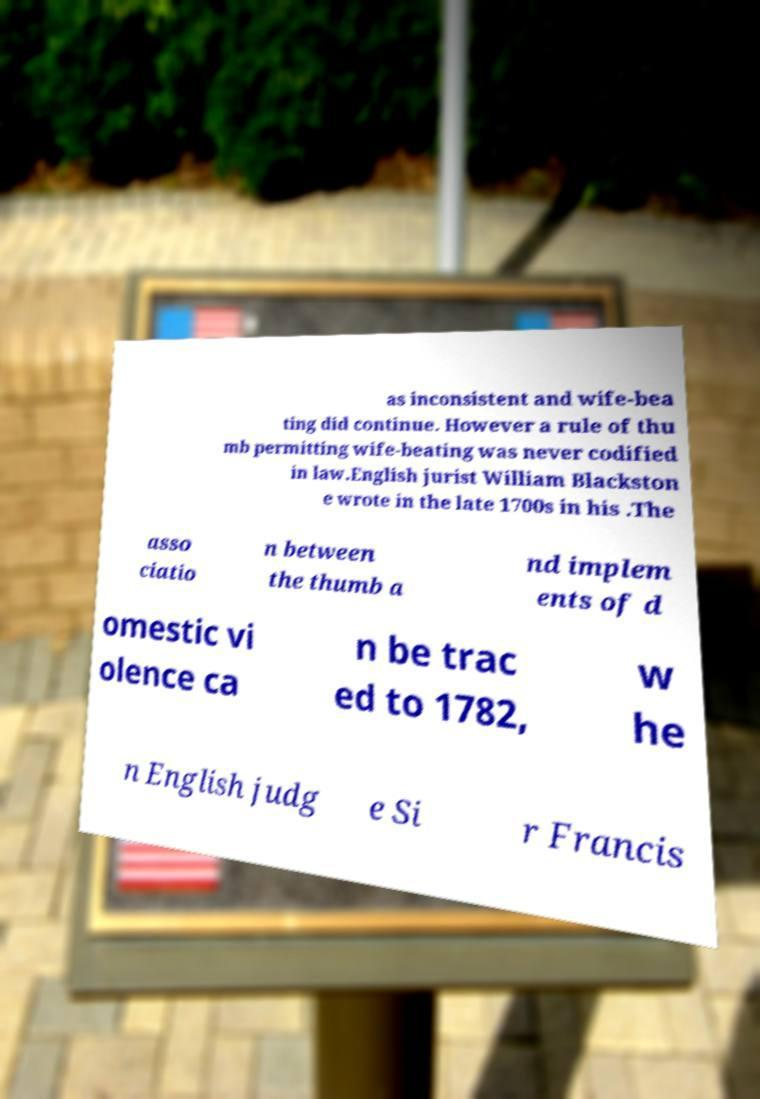Could you assist in decoding the text presented in this image and type it out clearly? as inconsistent and wife-bea ting did continue. However a rule of thu mb permitting wife-beating was never codified in law.English jurist William Blackston e wrote in the late 1700s in his .The asso ciatio n between the thumb a nd implem ents of d omestic vi olence ca n be trac ed to 1782, w he n English judg e Si r Francis 